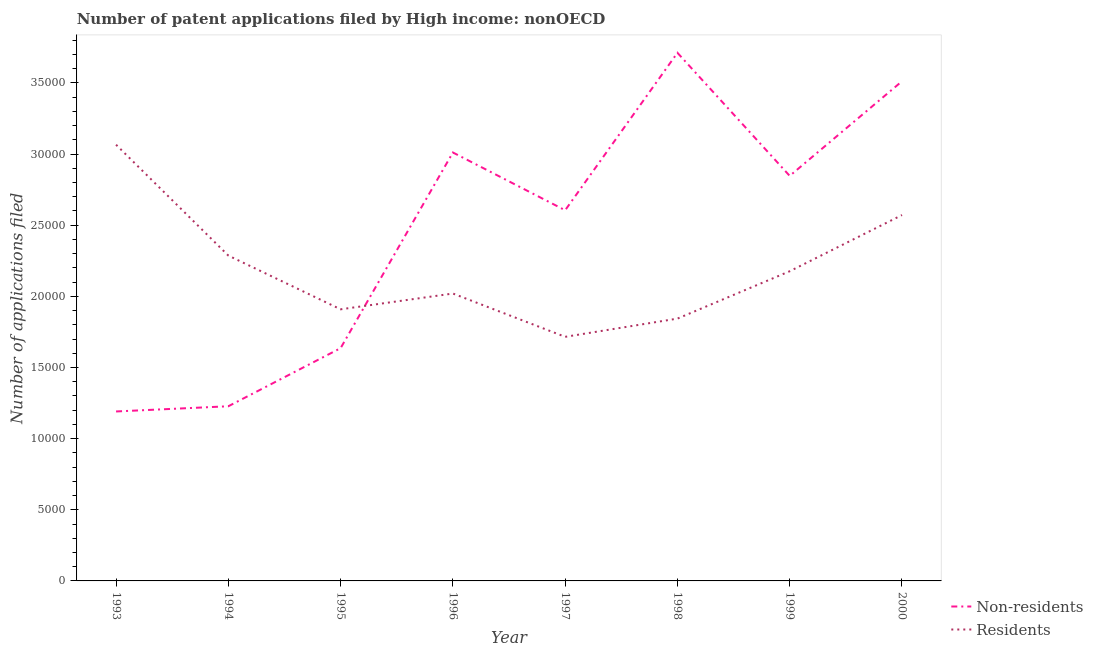Does the line corresponding to number of patent applications by residents intersect with the line corresponding to number of patent applications by non residents?
Your response must be concise. Yes. What is the number of patent applications by non residents in 1997?
Provide a succinct answer. 2.60e+04. Across all years, what is the maximum number of patent applications by non residents?
Provide a short and direct response. 3.71e+04. Across all years, what is the minimum number of patent applications by residents?
Your answer should be compact. 1.72e+04. In which year was the number of patent applications by non residents maximum?
Your response must be concise. 1998. In which year was the number of patent applications by non residents minimum?
Your answer should be compact. 1993. What is the total number of patent applications by non residents in the graph?
Provide a succinct answer. 1.97e+05. What is the difference between the number of patent applications by residents in 1997 and that in 2000?
Give a very brief answer. -8559. What is the difference between the number of patent applications by non residents in 1998 and the number of patent applications by residents in 1993?
Your answer should be very brief. 6459. What is the average number of patent applications by non residents per year?
Provide a short and direct response. 2.47e+04. In the year 1993, what is the difference between the number of patent applications by non residents and number of patent applications by residents?
Provide a succinct answer. -1.87e+04. What is the ratio of the number of patent applications by non residents in 1993 to that in 1995?
Offer a terse response. 0.73. Is the number of patent applications by residents in 1996 less than that in 1999?
Make the answer very short. Yes. Is the difference between the number of patent applications by residents in 1995 and 1997 greater than the difference between the number of patent applications by non residents in 1995 and 1997?
Offer a terse response. Yes. What is the difference between the highest and the second highest number of patent applications by non residents?
Provide a succinct answer. 1998. What is the difference between the highest and the lowest number of patent applications by non residents?
Offer a very short reply. 2.52e+04. In how many years, is the number of patent applications by non residents greater than the average number of patent applications by non residents taken over all years?
Offer a terse response. 5. Does the number of patent applications by non residents monotonically increase over the years?
Provide a short and direct response. No. Is the number of patent applications by non residents strictly greater than the number of patent applications by residents over the years?
Give a very brief answer. No. How many lines are there?
Provide a succinct answer. 2. How many years are there in the graph?
Provide a short and direct response. 8. What is the difference between two consecutive major ticks on the Y-axis?
Ensure brevity in your answer.  5000. Are the values on the major ticks of Y-axis written in scientific E-notation?
Your answer should be compact. No. Does the graph contain grids?
Offer a terse response. No. How are the legend labels stacked?
Offer a very short reply. Vertical. What is the title of the graph?
Your answer should be very brief. Number of patent applications filed by High income: nonOECD. What is the label or title of the X-axis?
Offer a terse response. Year. What is the label or title of the Y-axis?
Make the answer very short. Number of applications filed. What is the Number of applications filed in Non-residents in 1993?
Offer a terse response. 1.19e+04. What is the Number of applications filed in Residents in 1993?
Provide a succinct answer. 3.07e+04. What is the Number of applications filed of Non-residents in 1994?
Ensure brevity in your answer.  1.23e+04. What is the Number of applications filed of Residents in 1994?
Your answer should be very brief. 2.29e+04. What is the Number of applications filed of Non-residents in 1995?
Your answer should be very brief. 1.64e+04. What is the Number of applications filed of Residents in 1995?
Your answer should be very brief. 1.91e+04. What is the Number of applications filed in Non-residents in 1996?
Your answer should be compact. 3.01e+04. What is the Number of applications filed in Residents in 1996?
Your response must be concise. 2.02e+04. What is the Number of applications filed of Non-residents in 1997?
Make the answer very short. 2.60e+04. What is the Number of applications filed in Residents in 1997?
Offer a very short reply. 1.72e+04. What is the Number of applications filed of Non-residents in 1998?
Make the answer very short. 3.71e+04. What is the Number of applications filed in Residents in 1998?
Ensure brevity in your answer.  1.84e+04. What is the Number of applications filed of Non-residents in 1999?
Offer a terse response. 2.85e+04. What is the Number of applications filed of Residents in 1999?
Offer a terse response. 2.18e+04. What is the Number of applications filed in Non-residents in 2000?
Make the answer very short. 3.51e+04. What is the Number of applications filed in Residents in 2000?
Provide a short and direct response. 2.57e+04. Across all years, what is the maximum Number of applications filed of Non-residents?
Provide a short and direct response. 3.71e+04. Across all years, what is the maximum Number of applications filed in Residents?
Provide a short and direct response. 3.07e+04. Across all years, what is the minimum Number of applications filed of Non-residents?
Your response must be concise. 1.19e+04. Across all years, what is the minimum Number of applications filed of Residents?
Provide a succinct answer. 1.72e+04. What is the total Number of applications filed of Non-residents in the graph?
Make the answer very short. 1.97e+05. What is the total Number of applications filed in Residents in the graph?
Give a very brief answer. 1.76e+05. What is the difference between the Number of applications filed of Non-residents in 1993 and that in 1994?
Your answer should be compact. -366. What is the difference between the Number of applications filed of Residents in 1993 and that in 1994?
Keep it short and to the point. 7790. What is the difference between the Number of applications filed of Non-residents in 1993 and that in 1995?
Give a very brief answer. -4450. What is the difference between the Number of applications filed of Residents in 1993 and that in 1995?
Ensure brevity in your answer.  1.16e+04. What is the difference between the Number of applications filed in Non-residents in 1993 and that in 1996?
Your answer should be very brief. -1.82e+04. What is the difference between the Number of applications filed in Residents in 1993 and that in 1996?
Offer a terse response. 1.05e+04. What is the difference between the Number of applications filed in Non-residents in 1993 and that in 1997?
Provide a succinct answer. -1.41e+04. What is the difference between the Number of applications filed of Residents in 1993 and that in 1997?
Provide a short and direct response. 1.35e+04. What is the difference between the Number of applications filed in Non-residents in 1993 and that in 1998?
Provide a succinct answer. -2.52e+04. What is the difference between the Number of applications filed in Residents in 1993 and that in 1998?
Provide a short and direct response. 1.22e+04. What is the difference between the Number of applications filed in Non-residents in 1993 and that in 1999?
Provide a short and direct response. -1.66e+04. What is the difference between the Number of applications filed of Residents in 1993 and that in 1999?
Give a very brief answer. 8890. What is the difference between the Number of applications filed in Non-residents in 1993 and that in 2000?
Provide a short and direct response. -2.32e+04. What is the difference between the Number of applications filed of Residents in 1993 and that in 2000?
Ensure brevity in your answer.  4941. What is the difference between the Number of applications filed of Non-residents in 1994 and that in 1995?
Provide a succinct answer. -4084. What is the difference between the Number of applications filed of Residents in 1994 and that in 1995?
Offer a very short reply. 3776. What is the difference between the Number of applications filed of Non-residents in 1994 and that in 1996?
Provide a short and direct response. -1.78e+04. What is the difference between the Number of applications filed of Residents in 1994 and that in 1996?
Your answer should be compact. 2667. What is the difference between the Number of applications filed in Non-residents in 1994 and that in 1997?
Make the answer very short. -1.38e+04. What is the difference between the Number of applications filed of Residents in 1994 and that in 1997?
Make the answer very short. 5710. What is the difference between the Number of applications filed of Non-residents in 1994 and that in 1998?
Your response must be concise. -2.48e+04. What is the difference between the Number of applications filed in Residents in 1994 and that in 1998?
Your response must be concise. 4429. What is the difference between the Number of applications filed in Non-residents in 1994 and that in 1999?
Your answer should be very brief. -1.62e+04. What is the difference between the Number of applications filed of Residents in 1994 and that in 1999?
Give a very brief answer. 1100. What is the difference between the Number of applications filed of Non-residents in 1994 and that in 2000?
Make the answer very short. -2.28e+04. What is the difference between the Number of applications filed in Residents in 1994 and that in 2000?
Offer a very short reply. -2849. What is the difference between the Number of applications filed of Non-residents in 1995 and that in 1996?
Provide a short and direct response. -1.37e+04. What is the difference between the Number of applications filed in Residents in 1995 and that in 1996?
Provide a short and direct response. -1109. What is the difference between the Number of applications filed in Non-residents in 1995 and that in 1997?
Ensure brevity in your answer.  -9690. What is the difference between the Number of applications filed of Residents in 1995 and that in 1997?
Offer a terse response. 1934. What is the difference between the Number of applications filed of Non-residents in 1995 and that in 1998?
Your answer should be compact. -2.08e+04. What is the difference between the Number of applications filed of Residents in 1995 and that in 1998?
Ensure brevity in your answer.  653. What is the difference between the Number of applications filed of Non-residents in 1995 and that in 1999?
Your answer should be compact. -1.21e+04. What is the difference between the Number of applications filed in Residents in 1995 and that in 1999?
Your answer should be compact. -2676. What is the difference between the Number of applications filed of Non-residents in 1995 and that in 2000?
Ensure brevity in your answer.  -1.88e+04. What is the difference between the Number of applications filed of Residents in 1995 and that in 2000?
Your answer should be very brief. -6625. What is the difference between the Number of applications filed of Non-residents in 1996 and that in 1997?
Your response must be concise. 4059. What is the difference between the Number of applications filed of Residents in 1996 and that in 1997?
Make the answer very short. 3043. What is the difference between the Number of applications filed of Non-residents in 1996 and that in 1998?
Offer a terse response. -7005. What is the difference between the Number of applications filed in Residents in 1996 and that in 1998?
Your answer should be very brief. 1762. What is the difference between the Number of applications filed in Non-residents in 1996 and that in 1999?
Make the answer very short. 1645. What is the difference between the Number of applications filed in Residents in 1996 and that in 1999?
Your response must be concise. -1567. What is the difference between the Number of applications filed of Non-residents in 1996 and that in 2000?
Keep it short and to the point. -5007. What is the difference between the Number of applications filed in Residents in 1996 and that in 2000?
Make the answer very short. -5516. What is the difference between the Number of applications filed in Non-residents in 1997 and that in 1998?
Give a very brief answer. -1.11e+04. What is the difference between the Number of applications filed in Residents in 1997 and that in 1998?
Ensure brevity in your answer.  -1281. What is the difference between the Number of applications filed of Non-residents in 1997 and that in 1999?
Give a very brief answer. -2414. What is the difference between the Number of applications filed of Residents in 1997 and that in 1999?
Provide a short and direct response. -4610. What is the difference between the Number of applications filed of Non-residents in 1997 and that in 2000?
Your answer should be very brief. -9066. What is the difference between the Number of applications filed in Residents in 1997 and that in 2000?
Your answer should be very brief. -8559. What is the difference between the Number of applications filed in Non-residents in 1998 and that in 1999?
Make the answer very short. 8650. What is the difference between the Number of applications filed in Residents in 1998 and that in 1999?
Offer a terse response. -3329. What is the difference between the Number of applications filed in Non-residents in 1998 and that in 2000?
Your response must be concise. 1998. What is the difference between the Number of applications filed in Residents in 1998 and that in 2000?
Ensure brevity in your answer.  -7278. What is the difference between the Number of applications filed of Non-residents in 1999 and that in 2000?
Make the answer very short. -6652. What is the difference between the Number of applications filed in Residents in 1999 and that in 2000?
Ensure brevity in your answer.  -3949. What is the difference between the Number of applications filed in Non-residents in 1993 and the Number of applications filed in Residents in 1994?
Ensure brevity in your answer.  -1.10e+04. What is the difference between the Number of applications filed in Non-residents in 1993 and the Number of applications filed in Residents in 1995?
Keep it short and to the point. -7179. What is the difference between the Number of applications filed of Non-residents in 1993 and the Number of applications filed of Residents in 1996?
Make the answer very short. -8288. What is the difference between the Number of applications filed of Non-residents in 1993 and the Number of applications filed of Residents in 1997?
Offer a very short reply. -5245. What is the difference between the Number of applications filed in Non-residents in 1993 and the Number of applications filed in Residents in 1998?
Offer a very short reply. -6526. What is the difference between the Number of applications filed in Non-residents in 1993 and the Number of applications filed in Residents in 1999?
Provide a succinct answer. -9855. What is the difference between the Number of applications filed of Non-residents in 1993 and the Number of applications filed of Residents in 2000?
Ensure brevity in your answer.  -1.38e+04. What is the difference between the Number of applications filed in Non-residents in 1994 and the Number of applications filed in Residents in 1995?
Offer a very short reply. -6813. What is the difference between the Number of applications filed of Non-residents in 1994 and the Number of applications filed of Residents in 1996?
Your response must be concise. -7922. What is the difference between the Number of applications filed in Non-residents in 1994 and the Number of applications filed in Residents in 1997?
Your response must be concise. -4879. What is the difference between the Number of applications filed of Non-residents in 1994 and the Number of applications filed of Residents in 1998?
Your response must be concise. -6160. What is the difference between the Number of applications filed in Non-residents in 1994 and the Number of applications filed in Residents in 1999?
Provide a short and direct response. -9489. What is the difference between the Number of applications filed in Non-residents in 1994 and the Number of applications filed in Residents in 2000?
Offer a terse response. -1.34e+04. What is the difference between the Number of applications filed in Non-residents in 1995 and the Number of applications filed in Residents in 1996?
Offer a terse response. -3838. What is the difference between the Number of applications filed in Non-residents in 1995 and the Number of applications filed in Residents in 1997?
Make the answer very short. -795. What is the difference between the Number of applications filed in Non-residents in 1995 and the Number of applications filed in Residents in 1998?
Provide a short and direct response. -2076. What is the difference between the Number of applications filed in Non-residents in 1995 and the Number of applications filed in Residents in 1999?
Give a very brief answer. -5405. What is the difference between the Number of applications filed of Non-residents in 1995 and the Number of applications filed of Residents in 2000?
Keep it short and to the point. -9354. What is the difference between the Number of applications filed in Non-residents in 1996 and the Number of applications filed in Residents in 1997?
Your answer should be compact. 1.30e+04. What is the difference between the Number of applications filed in Non-residents in 1996 and the Number of applications filed in Residents in 1998?
Keep it short and to the point. 1.17e+04. What is the difference between the Number of applications filed of Non-residents in 1996 and the Number of applications filed of Residents in 1999?
Provide a succinct answer. 8344. What is the difference between the Number of applications filed in Non-residents in 1996 and the Number of applications filed in Residents in 2000?
Make the answer very short. 4395. What is the difference between the Number of applications filed in Non-residents in 1997 and the Number of applications filed in Residents in 1998?
Your answer should be very brief. 7614. What is the difference between the Number of applications filed in Non-residents in 1997 and the Number of applications filed in Residents in 1999?
Ensure brevity in your answer.  4285. What is the difference between the Number of applications filed of Non-residents in 1997 and the Number of applications filed of Residents in 2000?
Your answer should be compact. 336. What is the difference between the Number of applications filed of Non-residents in 1998 and the Number of applications filed of Residents in 1999?
Offer a terse response. 1.53e+04. What is the difference between the Number of applications filed of Non-residents in 1998 and the Number of applications filed of Residents in 2000?
Your answer should be compact. 1.14e+04. What is the difference between the Number of applications filed in Non-residents in 1999 and the Number of applications filed in Residents in 2000?
Your answer should be compact. 2750. What is the average Number of applications filed of Non-residents per year?
Offer a very short reply. 2.47e+04. What is the average Number of applications filed of Residents per year?
Your response must be concise. 2.20e+04. In the year 1993, what is the difference between the Number of applications filed in Non-residents and Number of applications filed in Residents?
Keep it short and to the point. -1.87e+04. In the year 1994, what is the difference between the Number of applications filed of Non-residents and Number of applications filed of Residents?
Offer a very short reply. -1.06e+04. In the year 1995, what is the difference between the Number of applications filed of Non-residents and Number of applications filed of Residents?
Your response must be concise. -2729. In the year 1996, what is the difference between the Number of applications filed of Non-residents and Number of applications filed of Residents?
Your response must be concise. 9911. In the year 1997, what is the difference between the Number of applications filed of Non-residents and Number of applications filed of Residents?
Provide a short and direct response. 8895. In the year 1998, what is the difference between the Number of applications filed in Non-residents and Number of applications filed in Residents?
Provide a short and direct response. 1.87e+04. In the year 1999, what is the difference between the Number of applications filed of Non-residents and Number of applications filed of Residents?
Provide a short and direct response. 6699. In the year 2000, what is the difference between the Number of applications filed in Non-residents and Number of applications filed in Residents?
Offer a very short reply. 9402. What is the ratio of the Number of applications filed of Non-residents in 1993 to that in 1994?
Your answer should be very brief. 0.97. What is the ratio of the Number of applications filed of Residents in 1993 to that in 1994?
Offer a very short reply. 1.34. What is the ratio of the Number of applications filed in Non-residents in 1993 to that in 1995?
Provide a succinct answer. 0.73. What is the ratio of the Number of applications filed in Residents in 1993 to that in 1995?
Offer a very short reply. 1.61. What is the ratio of the Number of applications filed in Non-residents in 1993 to that in 1996?
Make the answer very short. 0.4. What is the ratio of the Number of applications filed in Residents in 1993 to that in 1996?
Your answer should be very brief. 1.52. What is the ratio of the Number of applications filed of Non-residents in 1993 to that in 1997?
Your answer should be very brief. 0.46. What is the ratio of the Number of applications filed of Residents in 1993 to that in 1997?
Give a very brief answer. 1.79. What is the ratio of the Number of applications filed of Non-residents in 1993 to that in 1998?
Offer a very short reply. 0.32. What is the ratio of the Number of applications filed in Residents in 1993 to that in 1998?
Give a very brief answer. 1.66. What is the ratio of the Number of applications filed in Non-residents in 1993 to that in 1999?
Provide a succinct answer. 0.42. What is the ratio of the Number of applications filed of Residents in 1993 to that in 1999?
Your response must be concise. 1.41. What is the ratio of the Number of applications filed in Non-residents in 1993 to that in 2000?
Give a very brief answer. 0.34. What is the ratio of the Number of applications filed in Residents in 1993 to that in 2000?
Provide a short and direct response. 1.19. What is the ratio of the Number of applications filed in Non-residents in 1994 to that in 1995?
Provide a short and direct response. 0.75. What is the ratio of the Number of applications filed in Residents in 1994 to that in 1995?
Give a very brief answer. 1.2. What is the ratio of the Number of applications filed in Non-residents in 1994 to that in 1996?
Provide a short and direct response. 0.41. What is the ratio of the Number of applications filed of Residents in 1994 to that in 1996?
Keep it short and to the point. 1.13. What is the ratio of the Number of applications filed of Non-residents in 1994 to that in 1997?
Offer a very short reply. 0.47. What is the ratio of the Number of applications filed of Residents in 1994 to that in 1997?
Make the answer very short. 1.33. What is the ratio of the Number of applications filed in Non-residents in 1994 to that in 1998?
Ensure brevity in your answer.  0.33. What is the ratio of the Number of applications filed of Residents in 1994 to that in 1998?
Offer a very short reply. 1.24. What is the ratio of the Number of applications filed of Non-residents in 1994 to that in 1999?
Your answer should be very brief. 0.43. What is the ratio of the Number of applications filed in Residents in 1994 to that in 1999?
Provide a succinct answer. 1.05. What is the ratio of the Number of applications filed in Non-residents in 1994 to that in 2000?
Keep it short and to the point. 0.35. What is the ratio of the Number of applications filed in Residents in 1994 to that in 2000?
Provide a succinct answer. 0.89. What is the ratio of the Number of applications filed in Non-residents in 1995 to that in 1996?
Your response must be concise. 0.54. What is the ratio of the Number of applications filed in Residents in 1995 to that in 1996?
Make the answer very short. 0.95. What is the ratio of the Number of applications filed in Non-residents in 1995 to that in 1997?
Provide a short and direct response. 0.63. What is the ratio of the Number of applications filed of Residents in 1995 to that in 1997?
Provide a short and direct response. 1.11. What is the ratio of the Number of applications filed in Non-residents in 1995 to that in 1998?
Give a very brief answer. 0.44. What is the ratio of the Number of applications filed of Residents in 1995 to that in 1998?
Your response must be concise. 1.04. What is the ratio of the Number of applications filed in Non-residents in 1995 to that in 1999?
Give a very brief answer. 0.57. What is the ratio of the Number of applications filed in Residents in 1995 to that in 1999?
Offer a very short reply. 0.88. What is the ratio of the Number of applications filed in Non-residents in 1995 to that in 2000?
Provide a succinct answer. 0.47. What is the ratio of the Number of applications filed in Residents in 1995 to that in 2000?
Give a very brief answer. 0.74. What is the ratio of the Number of applications filed in Non-residents in 1996 to that in 1997?
Give a very brief answer. 1.16. What is the ratio of the Number of applications filed of Residents in 1996 to that in 1997?
Make the answer very short. 1.18. What is the ratio of the Number of applications filed in Non-residents in 1996 to that in 1998?
Your response must be concise. 0.81. What is the ratio of the Number of applications filed of Residents in 1996 to that in 1998?
Your response must be concise. 1.1. What is the ratio of the Number of applications filed in Non-residents in 1996 to that in 1999?
Ensure brevity in your answer.  1.06. What is the ratio of the Number of applications filed in Residents in 1996 to that in 1999?
Make the answer very short. 0.93. What is the ratio of the Number of applications filed in Non-residents in 1996 to that in 2000?
Provide a succinct answer. 0.86. What is the ratio of the Number of applications filed of Residents in 1996 to that in 2000?
Your answer should be compact. 0.79. What is the ratio of the Number of applications filed in Non-residents in 1997 to that in 1998?
Provide a short and direct response. 0.7. What is the ratio of the Number of applications filed in Residents in 1997 to that in 1998?
Your answer should be very brief. 0.93. What is the ratio of the Number of applications filed in Non-residents in 1997 to that in 1999?
Provide a succinct answer. 0.92. What is the ratio of the Number of applications filed of Residents in 1997 to that in 1999?
Offer a terse response. 0.79. What is the ratio of the Number of applications filed of Non-residents in 1997 to that in 2000?
Your response must be concise. 0.74. What is the ratio of the Number of applications filed of Residents in 1997 to that in 2000?
Provide a succinct answer. 0.67. What is the ratio of the Number of applications filed in Non-residents in 1998 to that in 1999?
Your answer should be very brief. 1.3. What is the ratio of the Number of applications filed of Residents in 1998 to that in 1999?
Your response must be concise. 0.85. What is the ratio of the Number of applications filed in Non-residents in 1998 to that in 2000?
Your answer should be compact. 1.06. What is the ratio of the Number of applications filed of Residents in 1998 to that in 2000?
Give a very brief answer. 0.72. What is the ratio of the Number of applications filed in Non-residents in 1999 to that in 2000?
Give a very brief answer. 0.81. What is the ratio of the Number of applications filed of Residents in 1999 to that in 2000?
Provide a succinct answer. 0.85. What is the difference between the highest and the second highest Number of applications filed of Non-residents?
Your answer should be very brief. 1998. What is the difference between the highest and the second highest Number of applications filed in Residents?
Give a very brief answer. 4941. What is the difference between the highest and the lowest Number of applications filed in Non-residents?
Your answer should be compact. 2.52e+04. What is the difference between the highest and the lowest Number of applications filed in Residents?
Provide a succinct answer. 1.35e+04. 